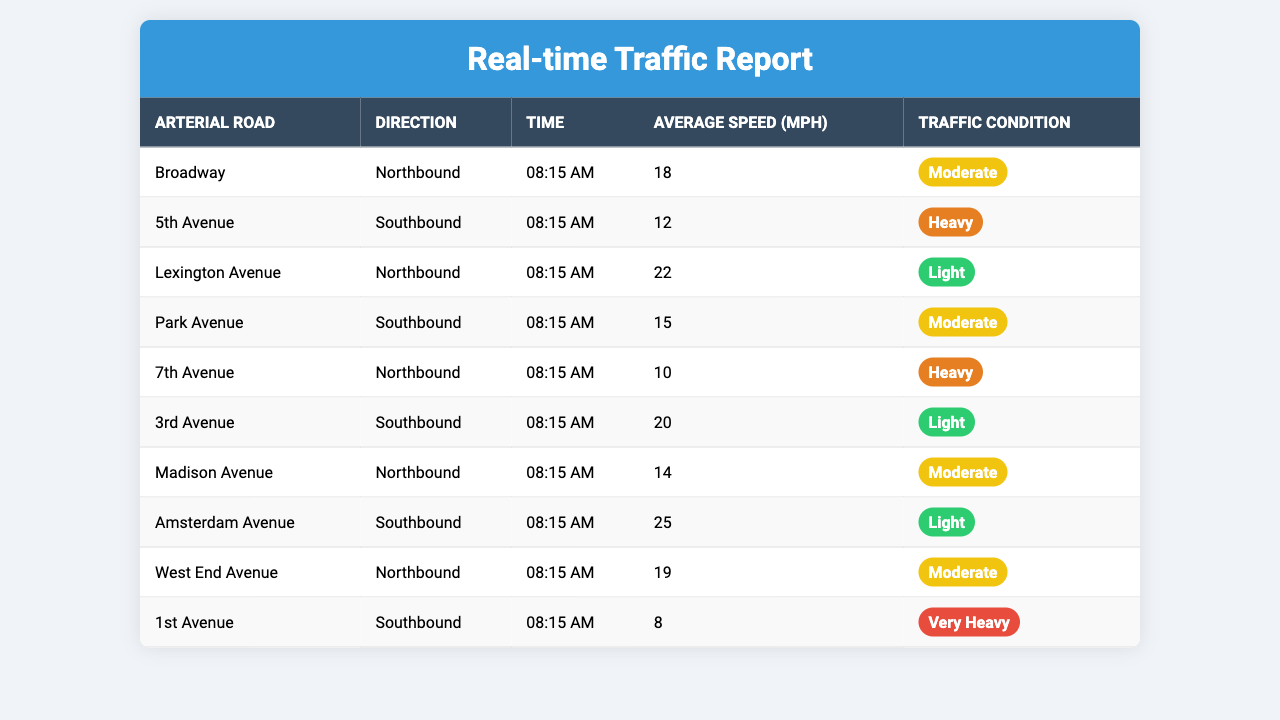What is the average speed on Broadway at 08:15 AM? The table shows that the average speed on Broadway at 08:15 AM is 18 mph.
Answer: 18 mph Which arterial road has the heaviest traffic condition? The table indicates that 5th Avenue with a speed of 12 mph has the heaviest traffic condition, followed by 7th Avenue at 10 mph and 1st Avenue at 8 mph.
Answer: 5th Avenue What is the average speed for northbound roads listed? The northbound speeds are 18 mph for Broadway, 22 mph for Lexington Avenue, 10 mph for 7th Avenue, 14 mph for Madison Avenue, and 19 mph for West End Avenue. Adding them gives 18 + 22 + 10 + 14 + 19 = 83 mph. There are 5 roads, so the average speed is 83/5 = 16.6 mph.
Answer: 16.6 mph Which road shows a traffic condition labeled as 'Light'? The roads with a 'Light' traffic condition are Lexington Avenue with 22 mph and Amsterdam Avenue with 25 mph.
Answer: Lexington Avenue, Amsterdam Avenue What is the difference in average speed between the road with the highest and lowest speeds among the southbound roads? The southbound roads with their speeds are: 5th Avenue at 12 mph, Park Avenue at 15 mph, 3rd Avenue at 20 mph, and 1st Avenue at 8 mph. The highest speed is 20 mph (3rd Avenue) and the lowest is 8 mph (1st Avenue). The difference is 20 - 8 = 12 mph.
Answer: 12 mph Is there any road where the average speed is lower than 10 mph? According to the table, 1st Avenue shows an average speed of 8 mph, which is lower than 10 mph.
Answer: Yes What is the median average speed of all listed arterial roads? The average speeds in ascending order are: 8, 10, 12, 14, 15, 18, 19, 20, 22, 25 mph (10 data points). The median is the average of the 5th and 6th values: (15 + 18) / 2 = 16.5 mph.
Answer: 16.5 mph For what road is the average speed and traffic condition both the best? The highest average speed with the best traffic condition is found on Amsterdam Avenue with 25 mph and a 'Light' traffic condition.
Answer: Amsterdam Avenue How many roads listed have a traffic condition of 'Moderate'? The roads under 'Moderate' traffic condition are Broadway, Park Avenue, and Madison Avenue, making a total of 3 roads.
Answer: 3 roads What is the speed limit for southbound roads compared to northbound roads? For southbound, the speeds are 12, 15, 20, and 8 mph with an average speed of 13.75 mph, while for northbound, the speeds are 18, 22, 10, 14, and 19 mph which average to 16.6 mph. Northbound is faster on average.
Answer: Northbound is faster 